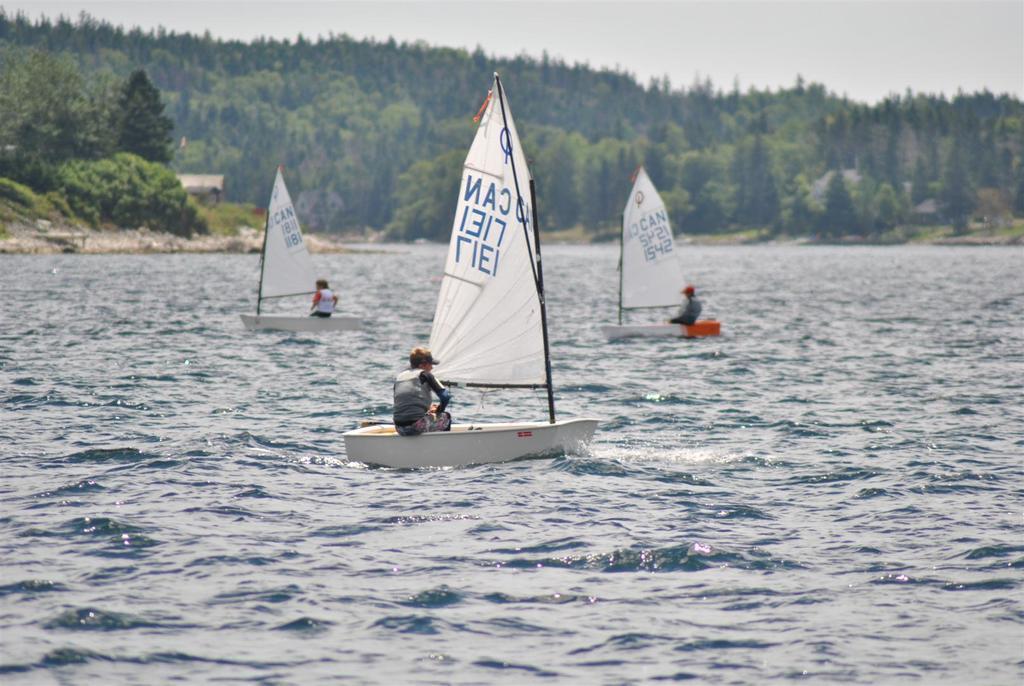Please provide a concise description of this image. At the bottom of the image there is water, above the water three persons are riding boots. Behind the boats there are some trees and hills. At the top of the image there is sky. 